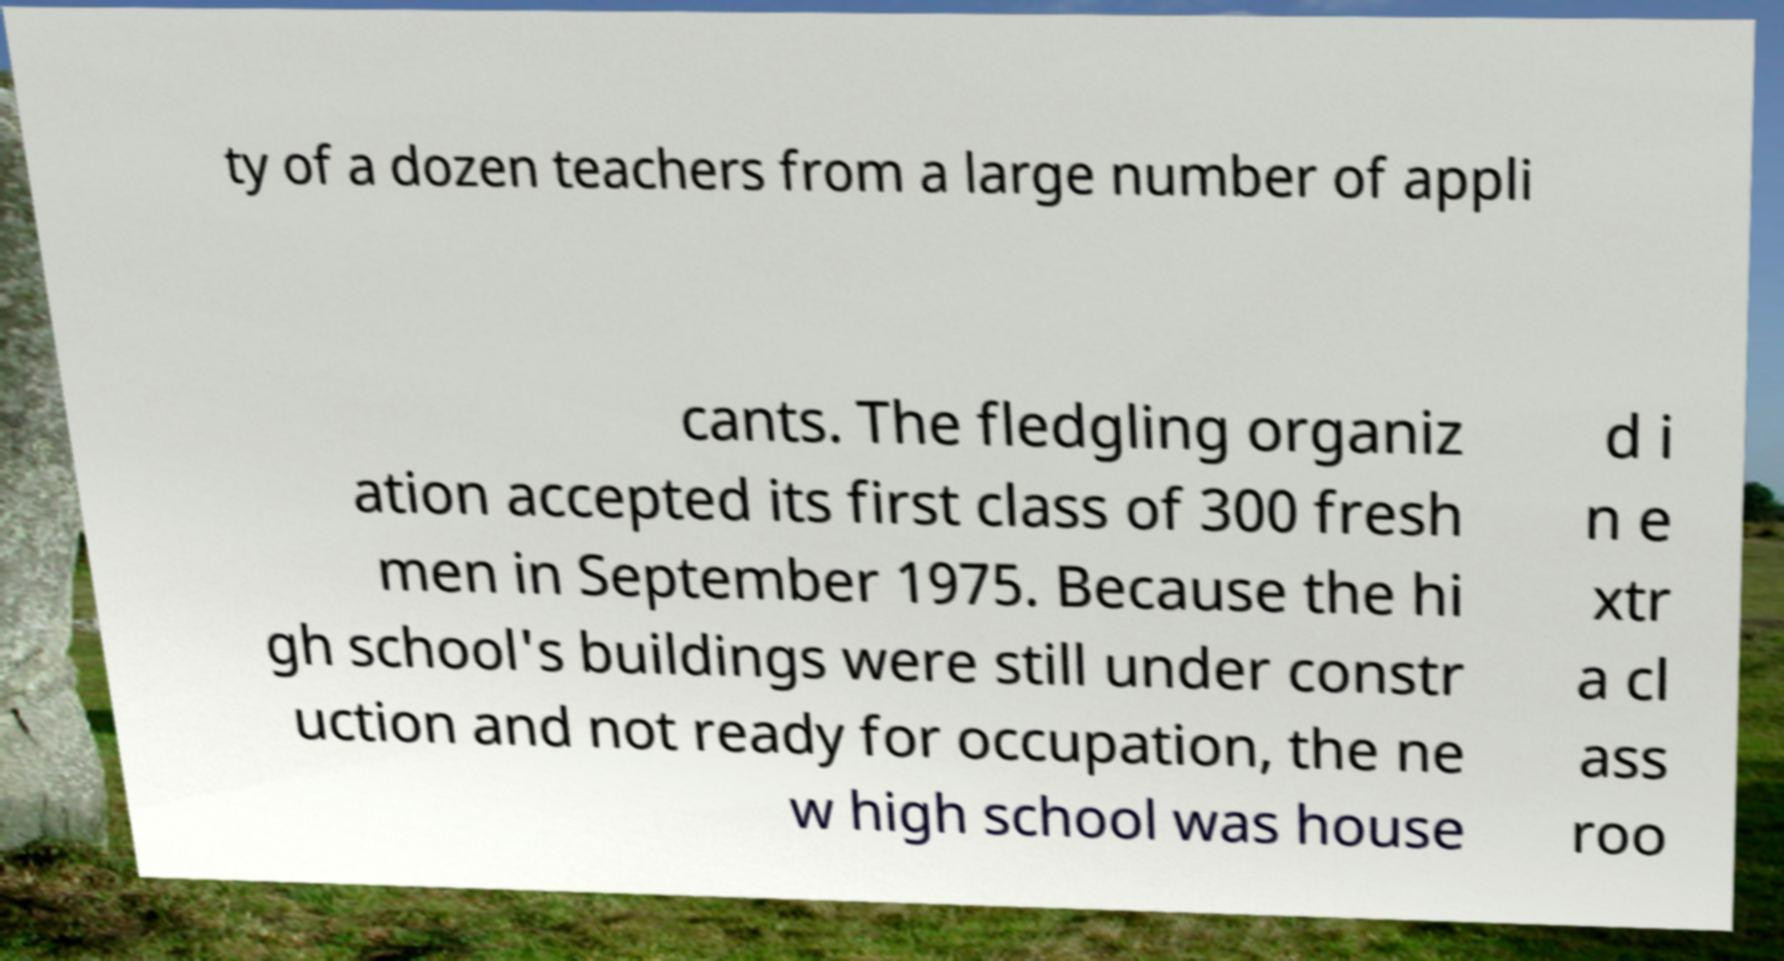Could you extract and type out the text from this image? ty of a dozen teachers from a large number of appli cants. The fledgling organiz ation accepted its first class of 300 fresh men in September 1975. Because the hi gh school's buildings were still under constr uction and not ready for occupation, the ne w high school was house d i n e xtr a cl ass roo 